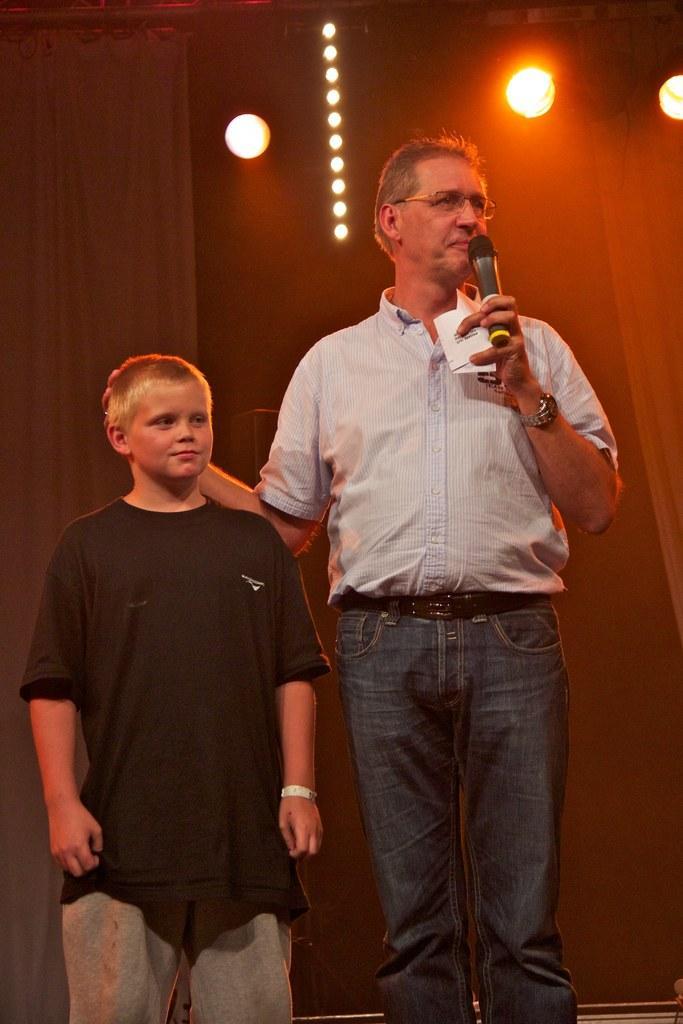Describe this image in one or two sentences. A boy and a man is standing. A man is holding a microphone in his hand and speaking and we can see three lights on the top 